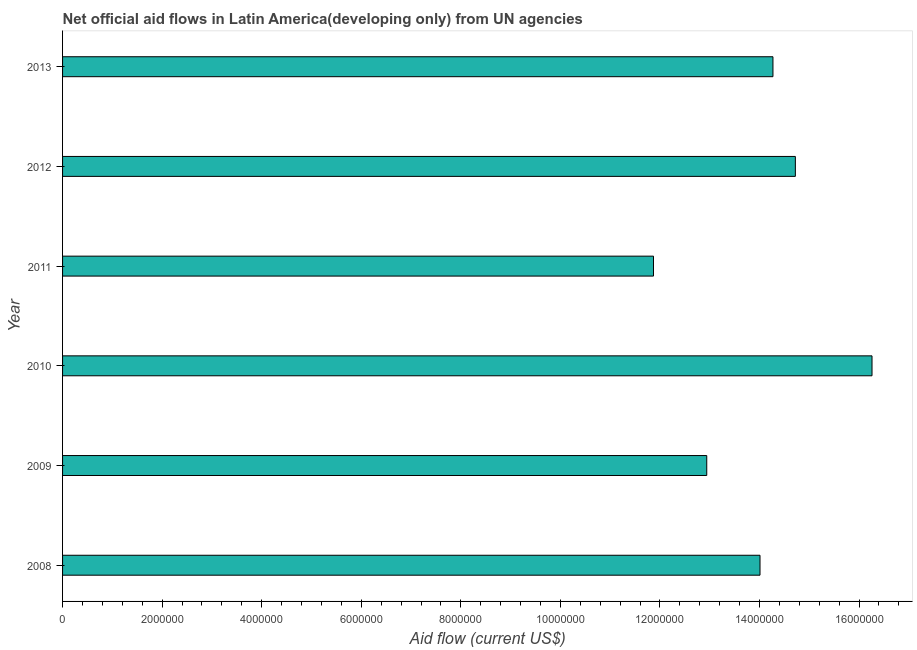Does the graph contain any zero values?
Your response must be concise. No. What is the title of the graph?
Make the answer very short. Net official aid flows in Latin America(developing only) from UN agencies. What is the label or title of the X-axis?
Offer a very short reply. Aid flow (current US$). What is the label or title of the Y-axis?
Offer a terse response. Year. What is the net official flows from un agencies in 2012?
Ensure brevity in your answer.  1.47e+07. Across all years, what is the maximum net official flows from un agencies?
Provide a short and direct response. 1.63e+07. Across all years, what is the minimum net official flows from un agencies?
Your response must be concise. 1.19e+07. In which year was the net official flows from un agencies minimum?
Provide a succinct answer. 2011. What is the sum of the net official flows from un agencies?
Your response must be concise. 8.41e+07. What is the difference between the net official flows from un agencies in 2008 and 2010?
Keep it short and to the point. -2.25e+06. What is the average net official flows from un agencies per year?
Your answer should be very brief. 1.40e+07. What is the median net official flows from un agencies?
Keep it short and to the point. 1.41e+07. In how many years, is the net official flows from un agencies greater than 4400000 US$?
Give a very brief answer. 6. What is the ratio of the net official flows from un agencies in 2011 to that in 2012?
Ensure brevity in your answer.  0.81. What is the difference between the highest and the second highest net official flows from un agencies?
Provide a short and direct response. 1.54e+06. Is the sum of the net official flows from un agencies in 2008 and 2011 greater than the maximum net official flows from un agencies across all years?
Offer a very short reply. Yes. What is the difference between the highest and the lowest net official flows from un agencies?
Keep it short and to the point. 4.39e+06. In how many years, is the net official flows from un agencies greater than the average net official flows from un agencies taken over all years?
Provide a succinct answer. 3. Are all the bars in the graph horizontal?
Your answer should be compact. Yes. How many years are there in the graph?
Offer a terse response. 6. What is the Aid flow (current US$) of 2008?
Ensure brevity in your answer.  1.40e+07. What is the Aid flow (current US$) of 2009?
Your answer should be compact. 1.29e+07. What is the Aid flow (current US$) of 2010?
Your response must be concise. 1.63e+07. What is the Aid flow (current US$) of 2011?
Provide a succinct answer. 1.19e+07. What is the Aid flow (current US$) in 2012?
Ensure brevity in your answer.  1.47e+07. What is the Aid flow (current US$) in 2013?
Your answer should be compact. 1.43e+07. What is the difference between the Aid flow (current US$) in 2008 and 2009?
Make the answer very short. 1.07e+06. What is the difference between the Aid flow (current US$) in 2008 and 2010?
Ensure brevity in your answer.  -2.25e+06. What is the difference between the Aid flow (current US$) in 2008 and 2011?
Provide a succinct answer. 2.14e+06. What is the difference between the Aid flow (current US$) in 2008 and 2012?
Keep it short and to the point. -7.10e+05. What is the difference between the Aid flow (current US$) in 2009 and 2010?
Your response must be concise. -3.32e+06. What is the difference between the Aid flow (current US$) in 2009 and 2011?
Make the answer very short. 1.07e+06. What is the difference between the Aid flow (current US$) in 2009 and 2012?
Give a very brief answer. -1.78e+06. What is the difference between the Aid flow (current US$) in 2009 and 2013?
Your response must be concise. -1.33e+06. What is the difference between the Aid flow (current US$) in 2010 and 2011?
Offer a terse response. 4.39e+06. What is the difference between the Aid flow (current US$) in 2010 and 2012?
Offer a very short reply. 1.54e+06. What is the difference between the Aid flow (current US$) in 2010 and 2013?
Offer a terse response. 1.99e+06. What is the difference between the Aid flow (current US$) in 2011 and 2012?
Provide a succinct answer. -2.85e+06. What is the difference between the Aid flow (current US$) in 2011 and 2013?
Provide a succinct answer. -2.40e+06. What is the ratio of the Aid flow (current US$) in 2008 to that in 2009?
Provide a succinct answer. 1.08. What is the ratio of the Aid flow (current US$) in 2008 to that in 2010?
Your response must be concise. 0.86. What is the ratio of the Aid flow (current US$) in 2008 to that in 2011?
Give a very brief answer. 1.18. What is the ratio of the Aid flow (current US$) in 2008 to that in 2012?
Provide a succinct answer. 0.95. What is the ratio of the Aid flow (current US$) in 2008 to that in 2013?
Give a very brief answer. 0.98. What is the ratio of the Aid flow (current US$) in 2009 to that in 2010?
Ensure brevity in your answer.  0.8. What is the ratio of the Aid flow (current US$) in 2009 to that in 2011?
Your answer should be very brief. 1.09. What is the ratio of the Aid flow (current US$) in 2009 to that in 2012?
Ensure brevity in your answer.  0.88. What is the ratio of the Aid flow (current US$) in 2009 to that in 2013?
Keep it short and to the point. 0.91. What is the ratio of the Aid flow (current US$) in 2010 to that in 2011?
Ensure brevity in your answer.  1.37. What is the ratio of the Aid flow (current US$) in 2010 to that in 2012?
Give a very brief answer. 1.1. What is the ratio of the Aid flow (current US$) in 2010 to that in 2013?
Offer a terse response. 1.14. What is the ratio of the Aid flow (current US$) in 2011 to that in 2012?
Your answer should be very brief. 0.81. What is the ratio of the Aid flow (current US$) in 2011 to that in 2013?
Provide a short and direct response. 0.83. What is the ratio of the Aid flow (current US$) in 2012 to that in 2013?
Provide a short and direct response. 1.03. 